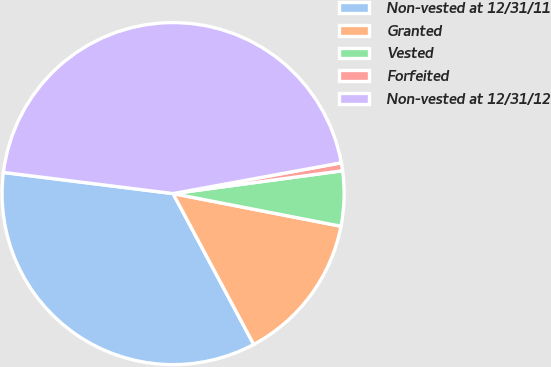<chart> <loc_0><loc_0><loc_500><loc_500><pie_chart><fcel>Non-vested at 12/31/11<fcel>Granted<fcel>Vested<fcel>Forfeited<fcel>Non-vested at 12/31/12<nl><fcel>34.79%<fcel>14.13%<fcel>5.19%<fcel>0.75%<fcel>45.14%<nl></chart> 